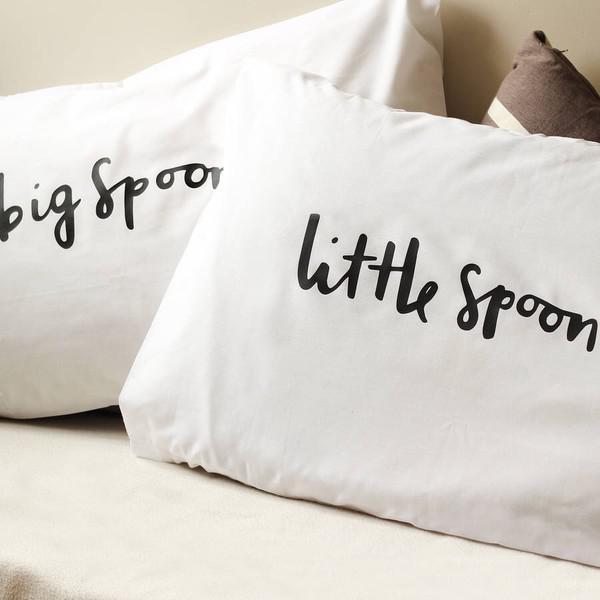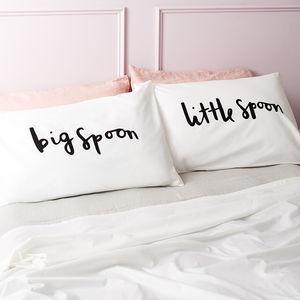The first image is the image on the left, the second image is the image on the right. Examine the images to the left and right. Is the description "Some of the pillows mention spoons." accurate? Answer yes or no. Yes. 